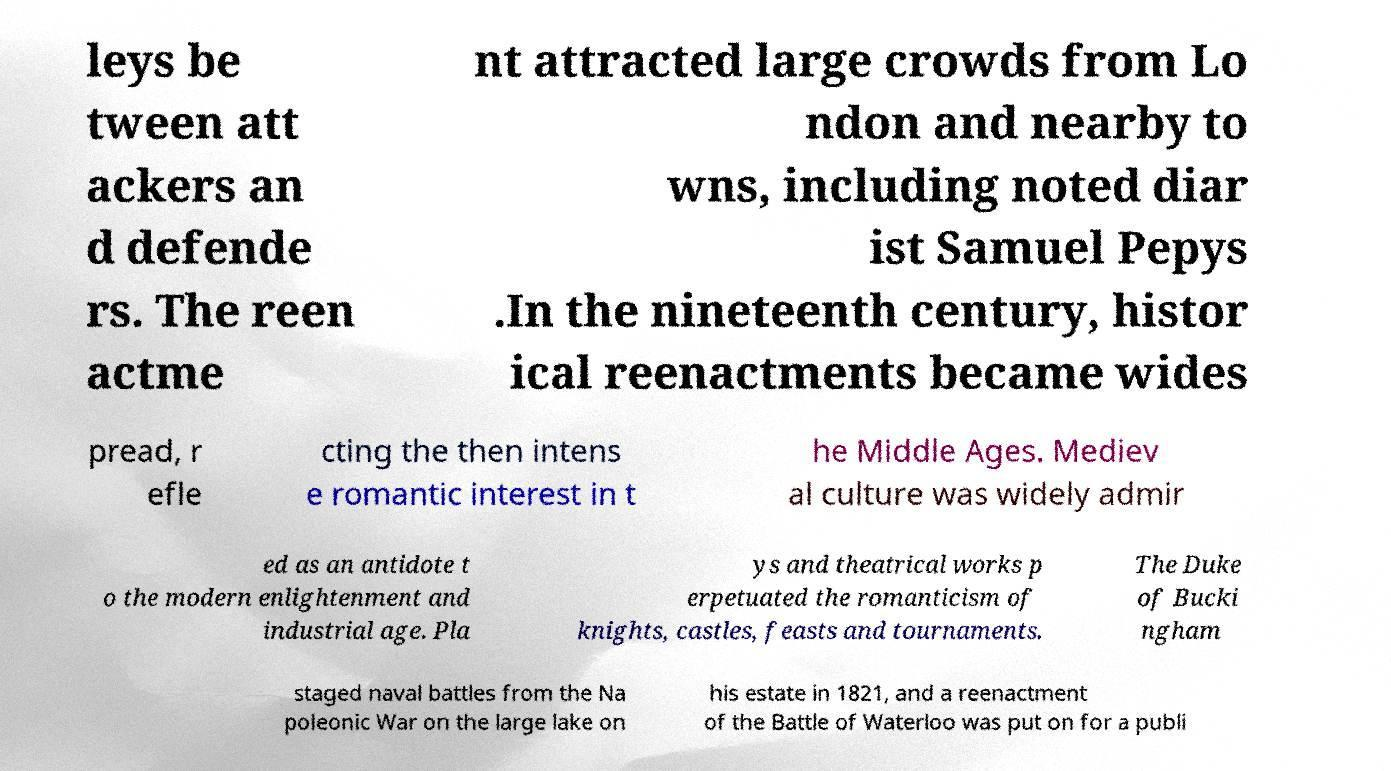There's text embedded in this image that I need extracted. Can you transcribe it verbatim? leys be tween att ackers an d defende rs. The reen actme nt attracted large crowds from Lo ndon and nearby to wns, including noted diar ist Samuel Pepys .In the nineteenth century, histor ical reenactments became wides pread, r efle cting the then intens e romantic interest in t he Middle Ages. Mediev al culture was widely admir ed as an antidote t o the modern enlightenment and industrial age. Pla ys and theatrical works p erpetuated the romanticism of knights, castles, feasts and tournaments. The Duke of Bucki ngham staged naval battles from the Na poleonic War on the large lake on his estate in 1821, and a reenactment of the Battle of Waterloo was put on for a publi 